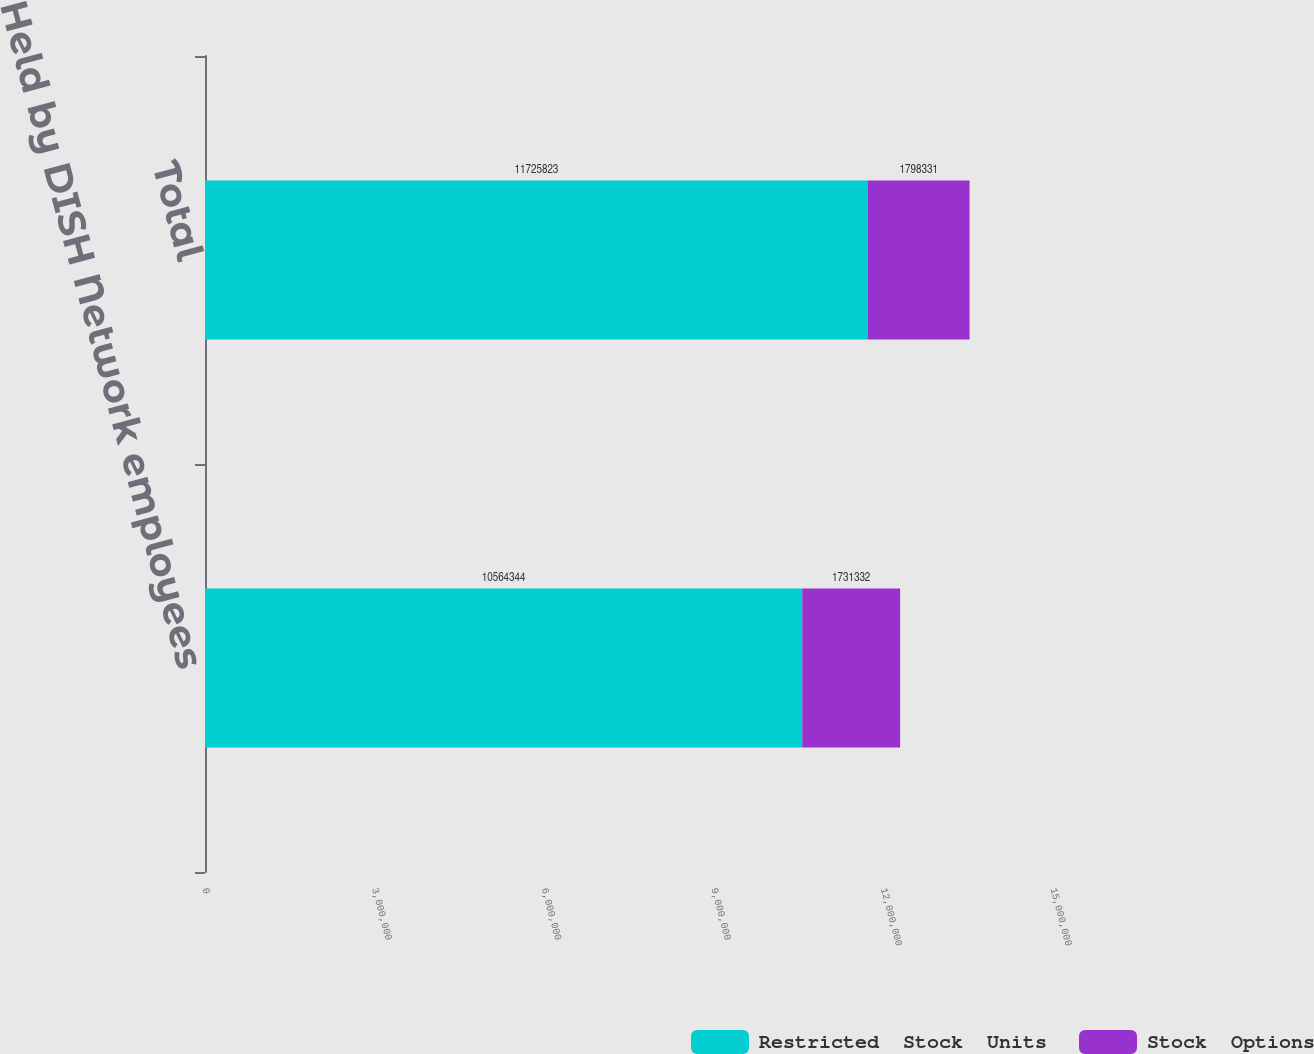Convert chart. <chart><loc_0><loc_0><loc_500><loc_500><stacked_bar_chart><ecel><fcel>Held by DISH Network employees<fcel>Total<nl><fcel>Restricted  Stock  Units<fcel>1.05643e+07<fcel>1.17258e+07<nl><fcel>Stock  Options<fcel>1.73133e+06<fcel>1.79833e+06<nl></chart> 